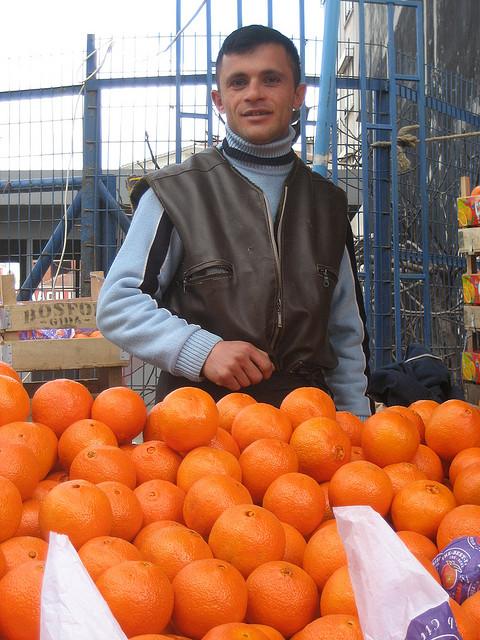Is this vibrant?
Concise answer only. Yes. Is he selling oranges?
Quick response, please. Yes. What is he wearing over his sweater?
Be succinct. Vest. 